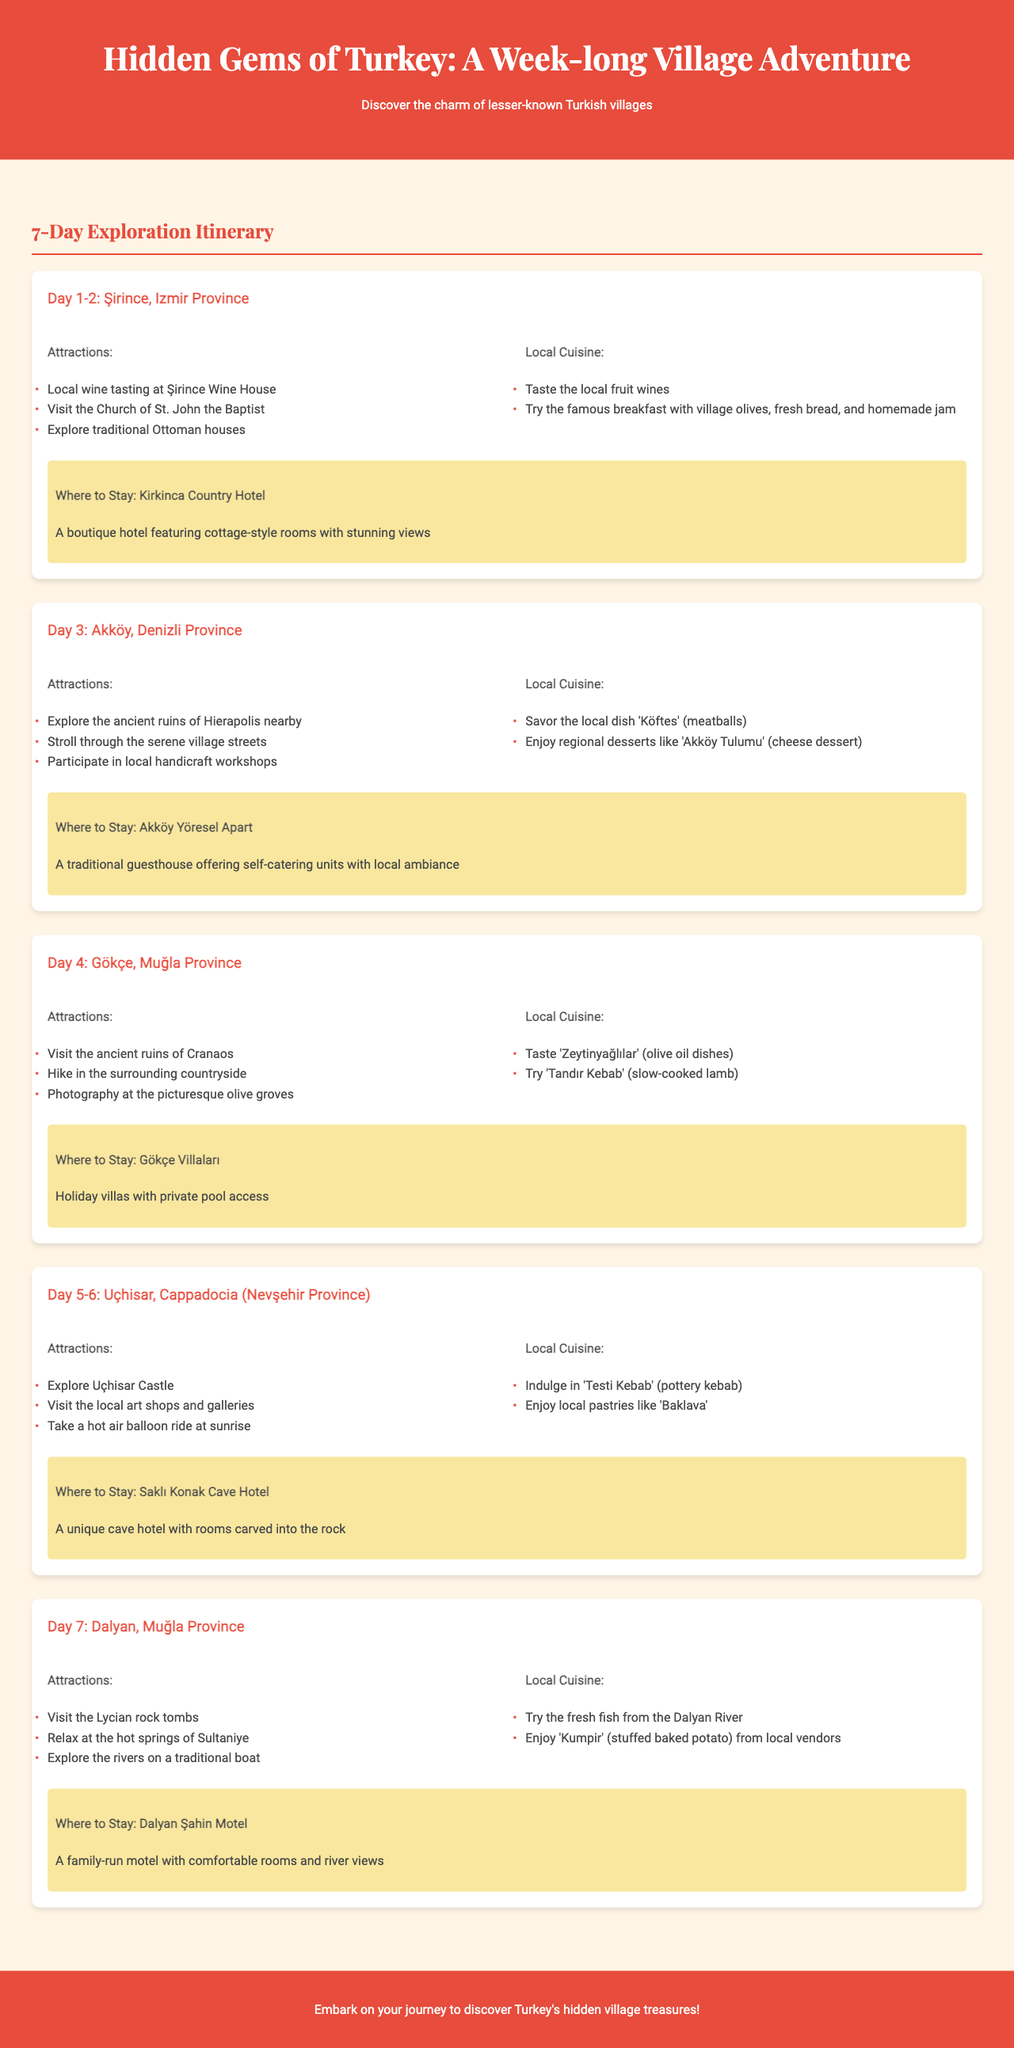What is the title of the itinerary? The title of the itinerary is stated at the beginning of the document.
Answer: Hidden Gems of Turkey: A Week-long Village Adventure What village is visited on Day 1-2? The document lists the villages in chronological order, starting from Day 1.
Answer: Şirince What local dish is recommended in Akköy? The document specifies local cuisine for each village, mentioning traditional dishes.
Answer: Köftes Where can you stay in Gökçe? Each village section provides accommodation options for visitors.
Answer: Gökçe Villaları How many days are allocated for Uçhisar? The itinerary details the number of days spent in each location.
Answer: 2 days What is a unique feature of the Saklı Konak Cave Hotel? The document describes unique accommodations available in the villages.
Answer: Rooms carved into the rock What type of cuisine is suggested in Dalyan? Local cuisine is highlighted in each village section with specific dishes.
Answer: Fresh fish from the Dalyan River What type of attractions can be found in Şirince? Each village section lists attractions to visit, showcasing local culture and history.
Answer: Local wine tasting at Şirince Wine House What is the format of the document? The structure follows a consistent format detailing village attractions, cuisine, and accommodations.
Answer: A week-long exploration itinerary 